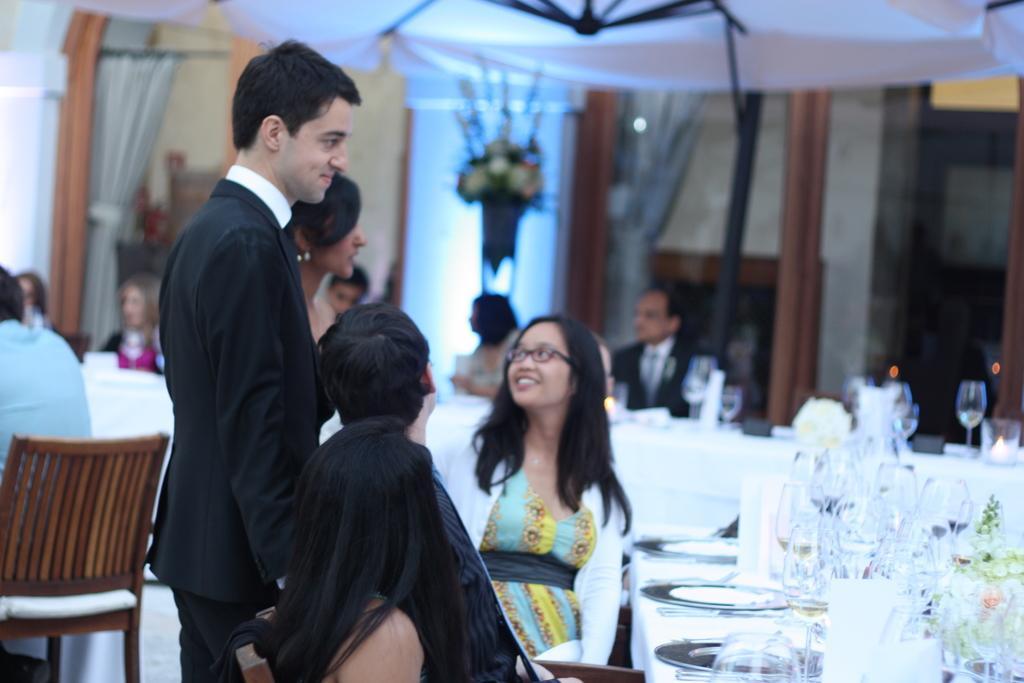In one or two sentences, can you explain what this image depicts? There is a man. He is wearing a suit and white color shirt. The women, the person and the women these three are sitting and looking at these both. In the background, there are the people. They are sitting. There is a curtain and flowers. On the left hand side, there is a man. He is sitting on the chair. 